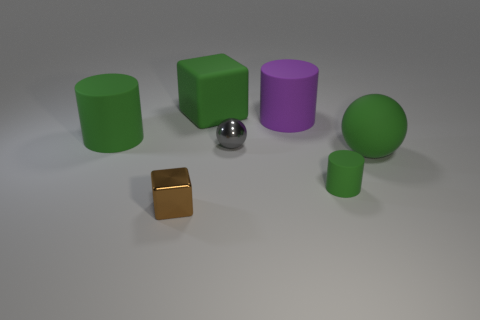Add 3 small brown shiny blocks. How many objects exist? 10 Subtract all purple cylinders. How many cylinders are left? 2 Subtract all gray spheres. How many green cylinders are left? 2 Subtract 2 cubes. How many cubes are left? 0 Subtract all green balls. How many balls are left? 1 Subtract all cylinders. How many objects are left? 4 Subtract 0 yellow balls. How many objects are left? 7 Subtract all brown cubes. Subtract all cyan balls. How many cubes are left? 1 Subtract all large purple spheres. Subtract all green matte blocks. How many objects are left? 6 Add 4 matte balls. How many matte balls are left? 5 